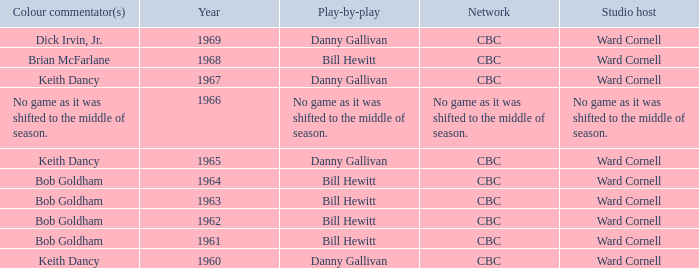Who gave the play by play commentary with studio host Ward Cornell? Danny Gallivan, Bill Hewitt, Danny Gallivan, Danny Gallivan, Bill Hewitt, Bill Hewitt, Bill Hewitt, Bill Hewitt, Danny Gallivan. 